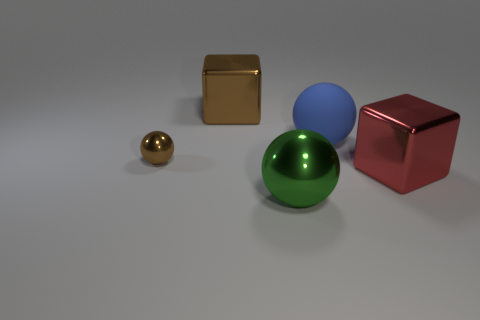Add 4 tiny metallic spheres. How many objects exist? 9 Subtract all large blue balls. How many balls are left? 2 Subtract all brown blocks. How many blocks are left? 1 Subtract all spheres. How many objects are left? 2 Subtract 0 red cylinders. How many objects are left? 5 Subtract 3 spheres. How many spheres are left? 0 Subtract all brown blocks. Subtract all red cylinders. How many blocks are left? 1 Subtract all blue cylinders. How many gray cubes are left? 0 Subtract all gray objects. Subtract all big red metallic cubes. How many objects are left? 4 Add 3 large blue spheres. How many large blue spheres are left? 4 